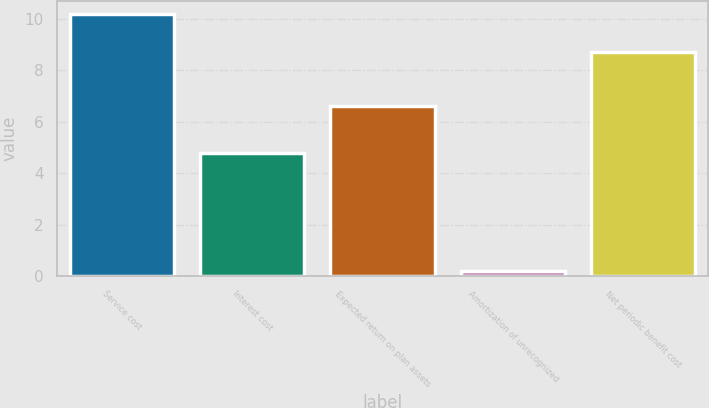<chart> <loc_0><loc_0><loc_500><loc_500><bar_chart><fcel>Service cost<fcel>Interest cost<fcel>Expected return on plan assets<fcel>Amortization of unrecognized<fcel>Net periodic benefit cost<nl><fcel>10.2<fcel>4.8<fcel>6.6<fcel>0.2<fcel>8.7<nl></chart> 